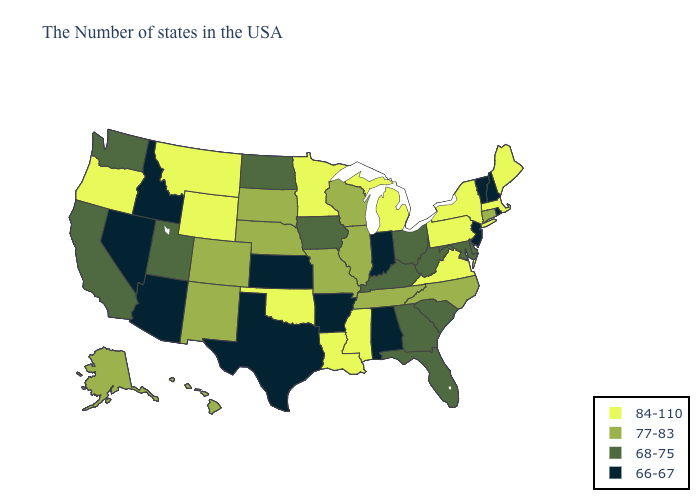How many symbols are there in the legend?
Keep it brief. 4. Name the states that have a value in the range 66-67?
Quick response, please. Rhode Island, New Hampshire, Vermont, New Jersey, Indiana, Alabama, Arkansas, Kansas, Texas, Arizona, Idaho, Nevada. Which states have the lowest value in the USA?
Write a very short answer. Rhode Island, New Hampshire, Vermont, New Jersey, Indiana, Alabama, Arkansas, Kansas, Texas, Arizona, Idaho, Nevada. Does Arkansas have a lower value than Idaho?
Concise answer only. No. What is the highest value in the South ?
Short answer required. 84-110. Among the states that border Wyoming , which have the highest value?
Short answer required. Montana. Name the states that have a value in the range 68-75?
Write a very short answer. Delaware, Maryland, South Carolina, West Virginia, Ohio, Florida, Georgia, Kentucky, Iowa, North Dakota, Utah, California, Washington. Does Florida have the lowest value in the South?
Keep it brief. No. Is the legend a continuous bar?
Write a very short answer. No. Name the states that have a value in the range 66-67?
Concise answer only. Rhode Island, New Hampshire, Vermont, New Jersey, Indiana, Alabama, Arkansas, Kansas, Texas, Arizona, Idaho, Nevada. What is the value of Idaho?
Concise answer only. 66-67. What is the value of Minnesota?
Answer briefly. 84-110. Name the states that have a value in the range 66-67?
Quick response, please. Rhode Island, New Hampshire, Vermont, New Jersey, Indiana, Alabama, Arkansas, Kansas, Texas, Arizona, Idaho, Nevada. What is the highest value in states that border Kentucky?
Answer briefly. 84-110. What is the value of Ohio?
Keep it brief. 68-75. 